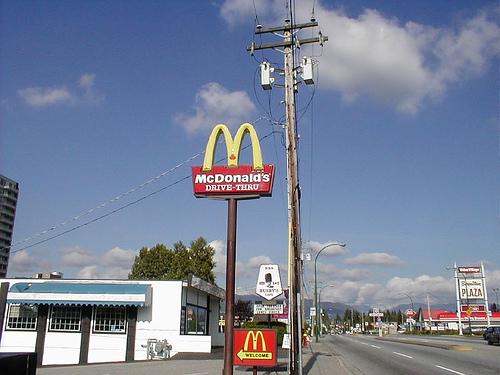What is in the picture?
Be succinct. Mcdonald's. How many streetlights do you see?
Be succinct. 1. Is this an old McDonalds?
Keep it brief. Yes. 